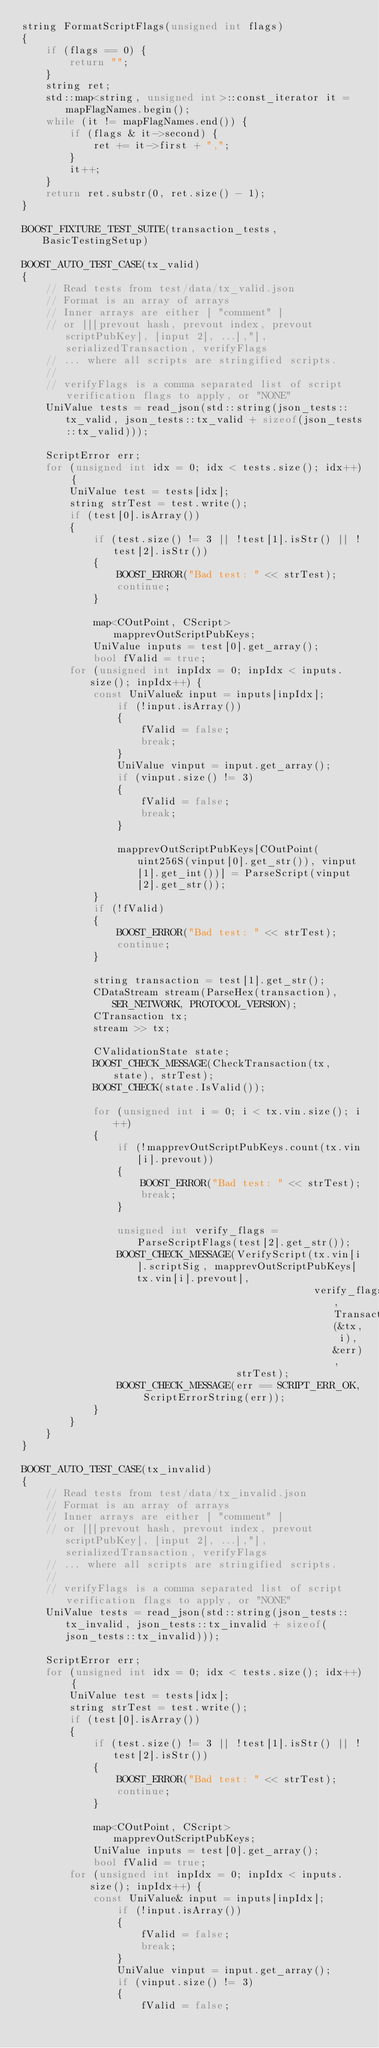<code> <loc_0><loc_0><loc_500><loc_500><_C++_>string FormatScriptFlags(unsigned int flags)
{
    if (flags == 0) {
        return "";
    }
    string ret;
    std::map<string, unsigned int>::const_iterator it = mapFlagNames.begin();
    while (it != mapFlagNames.end()) {
        if (flags & it->second) {
            ret += it->first + ",";
        }
        it++;
    }
    return ret.substr(0, ret.size() - 1);
}

BOOST_FIXTURE_TEST_SUITE(transaction_tests, BasicTestingSetup)

BOOST_AUTO_TEST_CASE(tx_valid)
{
    // Read tests from test/data/tx_valid.json
    // Format is an array of arrays
    // Inner arrays are either [ "comment" ]
    // or [[[prevout hash, prevout index, prevout scriptPubKey], [input 2], ...],"], serializedTransaction, verifyFlags
    // ... where all scripts are stringified scripts.
    //
    // verifyFlags is a comma separated list of script verification flags to apply, or "NONE"
    UniValue tests = read_json(std::string(json_tests::tx_valid, json_tests::tx_valid + sizeof(json_tests::tx_valid)));

    ScriptError err;
    for (unsigned int idx = 0; idx < tests.size(); idx++) {
        UniValue test = tests[idx];
        string strTest = test.write();
        if (test[0].isArray())
        {
            if (test.size() != 3 || !test[1].isStr() || !test[2].isStr())
            {
                BOOST_ERROR("Bad test: " << strTest);
                continue;
            }

            map<COutPoint, CScript> mapprevOutScriptPubKeys;
            UniValue inputs = test[0].get_array();
            bool fValid = true;
	    for (unsigned int inpIdx = 0; inpIdx < inputs.size(); inpIdx++) {
	        const UniValue& input = inputs[inpIdx];
                if (!input.isArray())
                {
                    fValid = false;
                    break;
                }
                UniValue vinput = input.get_array();
                if (vinput.size() != 3)
                {
                    fValid = false;
                    break;
                }

                mapprevOutScriptPubKeys[COutPoint(uint256S(vinput[0].get_str()), vinput[1].get_int())] = ParseScript(vinput[2].get_str());
            }
            if (!fValid)
            {
                BOOST_ERROR("Bad test: " << strTest);
                continue;
            }

            string transaction = test[1].get_str();
            CDataStream stream(ParseHex(transaction), SER_NETWORK, PROTOCOL_VERSION);
            CTransaction tx;
            stream >> tx;

            CValidationState state;
            BOOST_CHECK_MESSAGE(CheckTransaction(tx, state), strTest);
            BOOST_CHECK(state.IsValid());

            for (unsigned int i = 0; i < tx.vin.size(); i++)
            {
                if (!mapprevOutScriptPubKeys.count(tx.vin[i].prevout))
                {
                    BOOST_ERROR("Bad test: " << strTest);
                    break;
                }

                unsigned int verify_flags = ParseScriptFlags(test[2].get_str());
                BOOST_CHECK_MESSAGE(VerifyScript(tx.vin[i].scriptSig, mapprevOutScriptPubKeys[tx.vin[i].prevout],
                                                 verify_flags, TransactionSignatureChecker(&tx, i), &err),
                                    strTest);
                BOOST_CHECK_MESSAGE(err == SCRIPT_ERR_OK, ScriptErrorString(err));
            }
        }
    }
}

BOOST_AUTO_TEST_CASE(tx_invalid)
{
    // Read tests from test/data/tx_invalid.json
    // Format is an array of arrays
    // Inner arrays are either [ "comment" ]
    // or [[[prevout hash, prevout index, prevout scriptPubKey], [input 2], ...],"], serializedTransaction, verifyFlags
    // ... where all scripts are stringified scripts.
    //
    // verifyFlags is a comma separated list of script verification flags to apply, or "NONE"
    UniValue tests = read_json(std::string(json_tests::tx_invalid, json_tests::tx_invalid + sizeof(json_tests::tx_invalid)));

    ScriptError err;
    for (unsigned int idx = 0; idx < tests.size(); idx++) {
        UniValue test = tests[idx];
        string strTest = test.write();
        if (test[0].isArray())
        {
            if (test.size() != 3 || !test[1].isStr() || !test[2].isStr())
            {
                BOOST_ERROR("Bad test: " << strTest);
                continue;
            }

            map<COutPoint, CScript> mapprevOutScriptPubKeys;
            UniValue inputs = test[0].get_array();
            bool fValid = true;
	    for (unsigned int inpIdx = 0; inpIdx < inputs.size(); inpIdx++) {
	        const UniValue& input = inputs[inpIdx];
                if (!input.isArray())
                {
                    fValid = false;
                    break;
                }
                UniValue vinput = input.get_array();
                if (vinput.size() != 3)
                {
                    fValid = false;</code> 